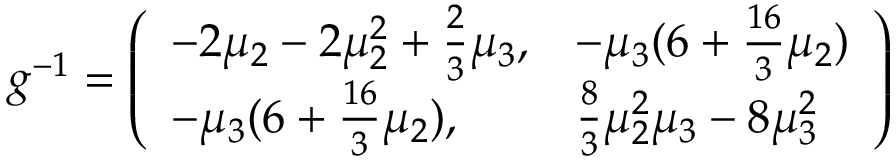<formula> <loc_0><loc_0><loc_500><loc_500>g ^ { - 1 } = \left ( \begin{array} { l l } { { - 2 \mu _ { 2 } - 2 \mu _ { 2 } ^ { 2 } + \frac { 2 } { 3 } \mu _ { 3 } , } } & { { - \mu _ { 3 } ( 6 + \frac { 1 6 } { 3 } \mu _ { 2 } ) } } \\ { { - \mu _ { 3 } ( 6 + \frac { 1 6 } { 3 } \mu _ { 2 } ) , } } & { { \frac { 8 } { 3 } \mu _ { 2 } ^ { 2 } \mu _ { 3 } - 8 \mu _ { 3 } ^ { 2 } } } \end{array} \right )</formula> 